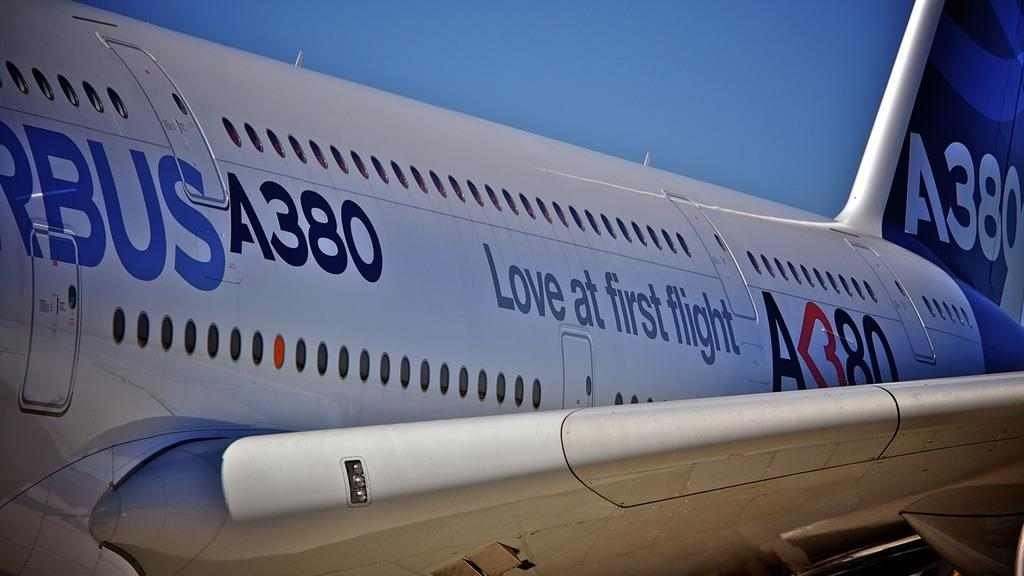<image>
Relay a brief, clear account of the picture shown. A large airplane A380 with the quote love at first flight. 